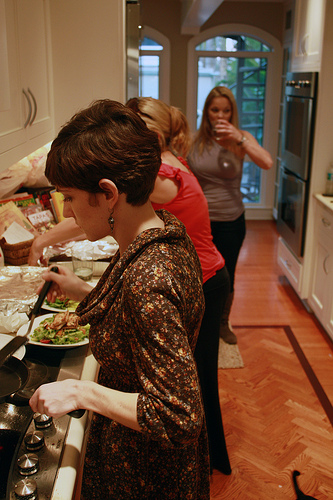Please provide the bounding box coordinate of the region this sentence describes: woman is drinking from a cup. [0.55, 0.16, 0.7, 0.44]. This box frames a woman involved in the action of drinking from a cup. 